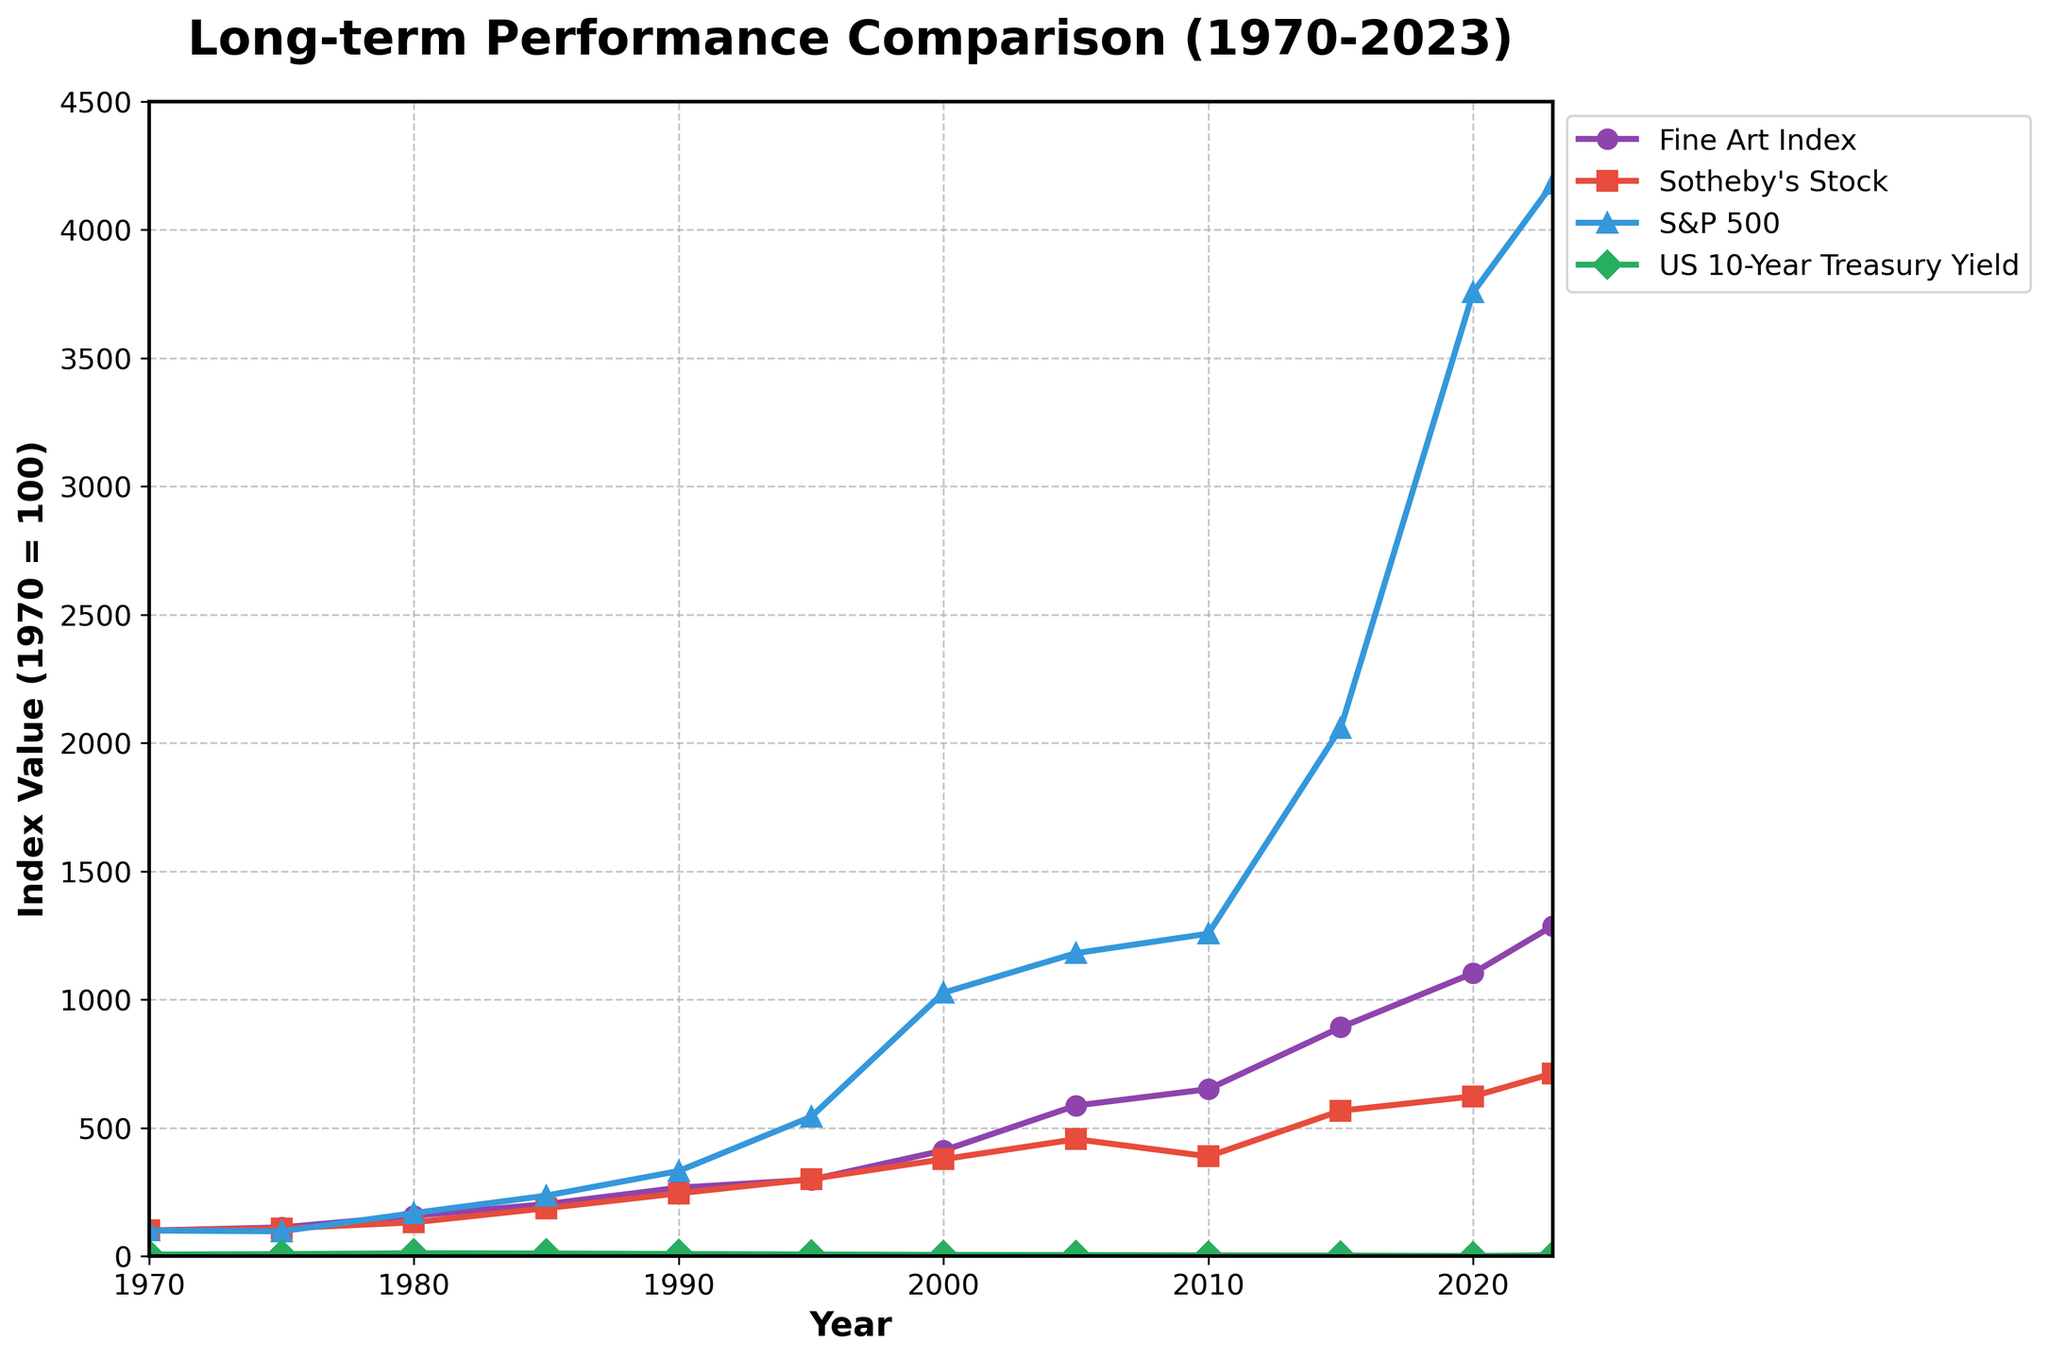What has the highest index value in 2023? Looking at the endpoint of each line corresponding to 2023, the S&P 500 has the tallest line (index value = 4179), indicating the highest index value.
Answer: S&P 500 Between art investments and Sotheby's stock, which one had a higher index value in 2000? In 2000, the index value for Fine Art is 412 while for Sotheby's Stock it is 378. Fine Art Index has a higher value.
Answer: Fine Art Index How did the US 10-Year Treasury Yield change from 2010 to 2020? Observing the graph from 2010 to 2020 for the Treasury Yield curve, it decreases from 3.22 to 0.93.
Answer: Decreased What is the difference between the Fine Art Index and S&P 500 in 1980? In 1980, the Fine Art Index is 158 and the S&P 500 is 168. The difference is 168 - 158 = 10.
Answer: 10 Which year showed the highest index value for Sotheby's stock? The peak of the Sotheby's stock curve is in 2023, where its value is at 712.
Answer: 2023 What was the general trend for Fine Art Index from 1970 to 2023? The Fine Art Index curve shows a general upward trend, consistently increasing over time from 100 in 1970 to 1287 in 2023.
Answer: Upward Trend Compare the performance of Fine Art Index and US 10-Year Treasury Yield between 1970 and 2000. In 1970, Fine Art Index is 100 and US 10-Year Treasury Yield is 6.39. In 2000, Fine Art Index is 412 and US 10-Year Treasury Yield is 5.11. The Fine Art Index increased significantly while the Treasury Yield decreased slightly.
Answer: Fine Art Index increased, Treasury Yield decreased Which asset had the least consistent growth over the period from 1970 to 2023? The curve plotting US 10-Year Treasury Yield shows high fluctuations and inconsistency over time, compared to other assets which show more steady trends.
Answer: US 10-Year Treasury Yield By how much did the value of S&P 500 surpass the Fine Art Index in 2020? In 2020, the S&P 500 value is 3756 and the Fine Art Index is 1103. The difference is 3756 - 1103 = 2653.
Answer: 2653 